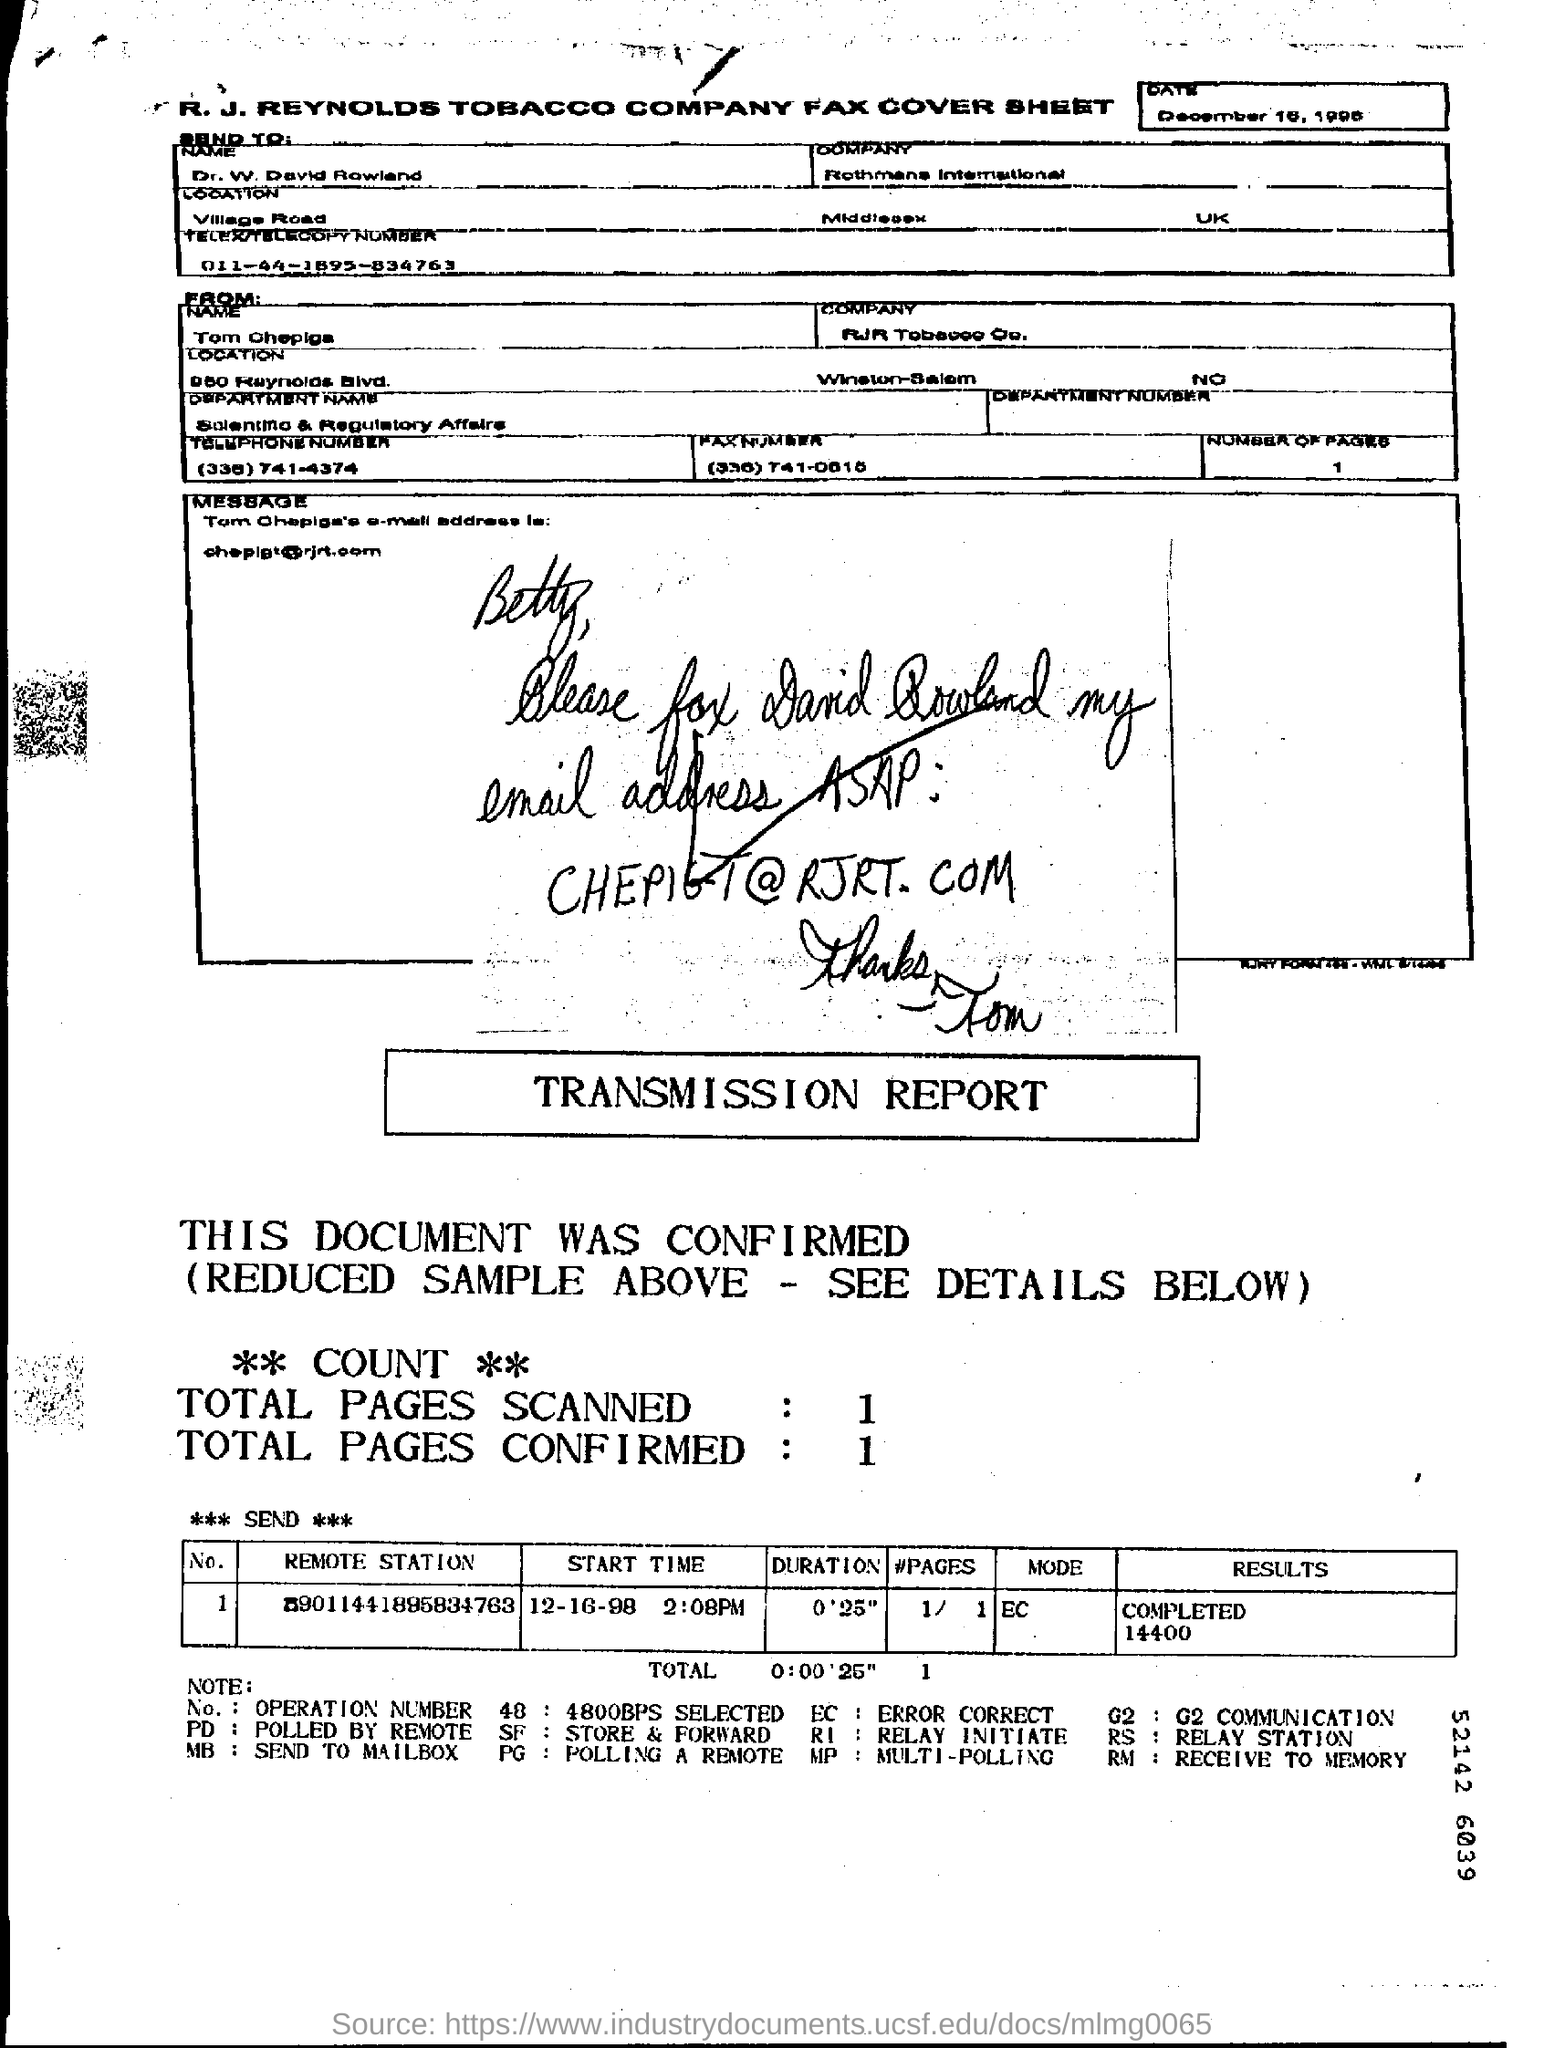What date was the fax sent? The fax was sent on December 16, 1998, as stated at the top of the transmission report. Can you tell me the time when this fax was transmitted? The transmission time is marked as 2:08 PM on the report under the 'START TIME' column. 